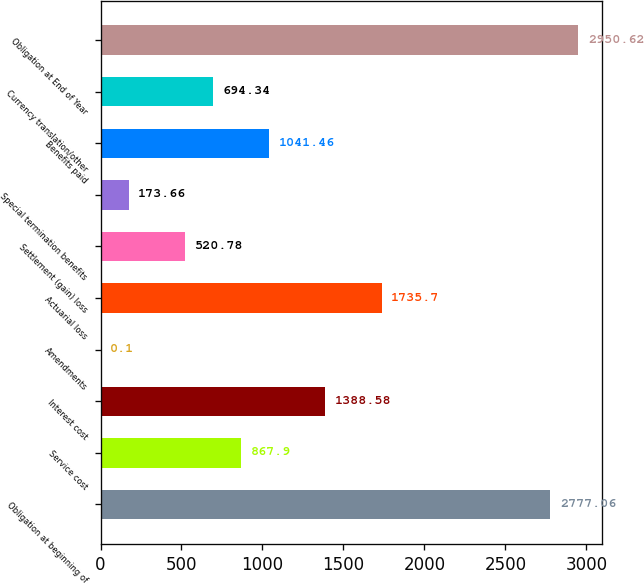Convert chart to OTSL. <chart><loc_0><loc_0><loc_500><loc_500><bar_chart><fcel>Obligation at beginning of<fcel>Service cost<fcel>Interest cost<fcel>Amendments<fcel>Actuarial loss<fcel>Settlement (gain) loss<fcel>Special termination benefits<fcel>Benefits paid<fcel>Currency translation/other<fcel>Obligation at End of Year<nl><fcel>2777.06<fcel>867.9<fcel>1388.58<fcel>0.1<fcel>1735.7<fcel>520.78<fcel>173.66<fcel>1041.46<fcel>694.34<fcel>2950.62<nl></chart> 